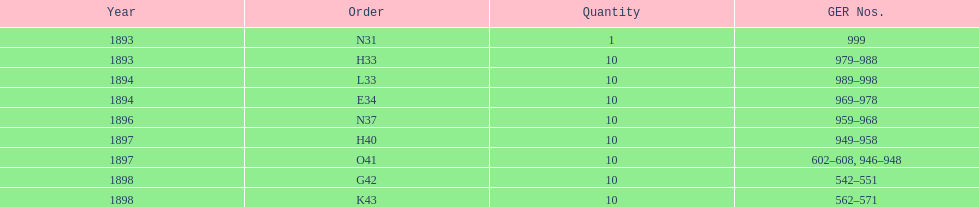What is the duration of the time span in years? 5 years. 